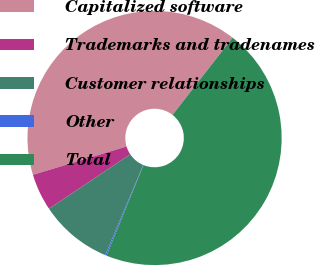Convert chart to OTSL. <chart><loc_0><loc_0><loc_500><loc_500><pie_chart><fcel>Capitalized software<fcel>Trademarks and tradenames<fcel>Customer relationships<fcel>Other<fcel>Total<nl><fcel>40.2%<fcel>4.72%<fcel>9.26%<fcel>0.17%<fcel>45.65%<nl></chart> 